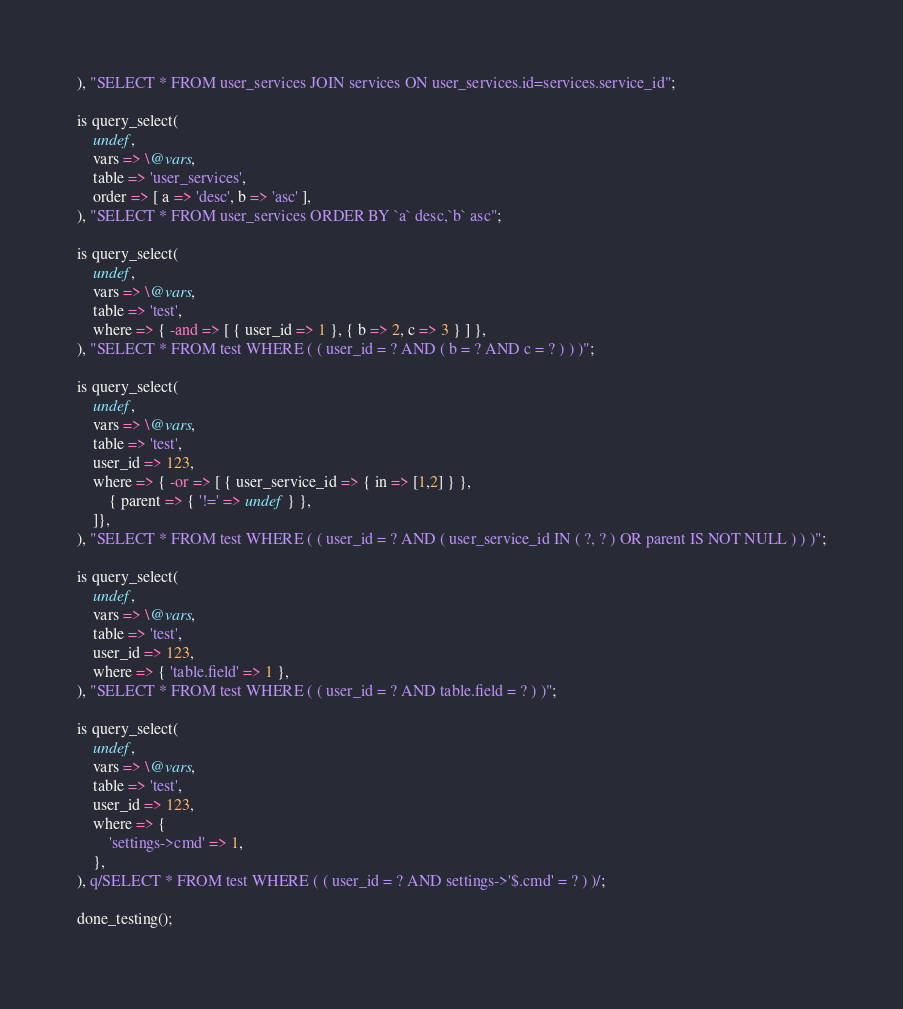<code> <loc_0><loc_0><loc_500><loc_500><_Perl_>), "SELECT * FROM user_services JOIN services ON user_services.id=services.service_id";

is query_select(
    undef,
    vars => \@vars,
    table => 'user_services',
    order => [ a => 'desc', b => 'asc' ],
), "SELECT * FROM user_services ORDER BY `a` desc,`b` asc";

is query_select(
    undef,
    vars => \@vars,
    table => 'test',
    where => { -and => [ { user_id => 1 }, { b => 2, c => 3 } ] },
), "SELECT * FROM test WHERE ( ( user_id = ? AND ( b = ? AND c = ? ) ) )";

is query_select(
    undef,
    vars => \@vars,
    table => 'test',
    user_id => 123,
    where => { -or => [ { user_service_id => { in => [1,2] } },
        { parent => { '!=' => undef } },
    ]},
), "SELECT * FROM test WHERE ( ( user_id = ? AND ( user_service_id IN ( ?, ? ) OR parent IS NOT NULL ) ) )";

is query_select(
    undef,
    vars => \@vars,
    table => 'test',
    user_id => 123,
    where => { 'table.field' => 1 },
), "SELECT * FROM test WHERE ( ( user_id = ? AND table.field = ? ) )";

is query_select(
    undef,
    vars => \@vars,
    table => 'test',
    user_id => 123,
    where => {
        'settings->cmd' => 1,
    },
), q/SELECT * FROM test WHERE ( ( user_id = ? AND settings->'$.cmd' = ? ) )/;

done_testing();
</code> 